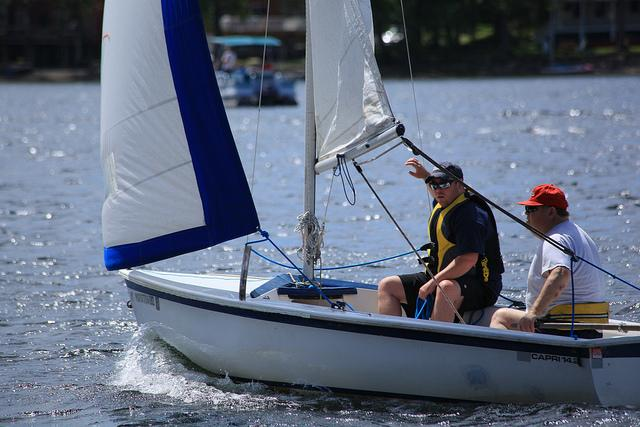What color is the border of the sail on the small boat? blue 